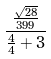Convert formula to latex. <formula><loc_0><loc_0><loc_500><loc_500>\frac { \frac { \sqrt { 2 8 } } { 3 9 9 } } { \frac { 4 } { 4 } + 3 }</formula> 